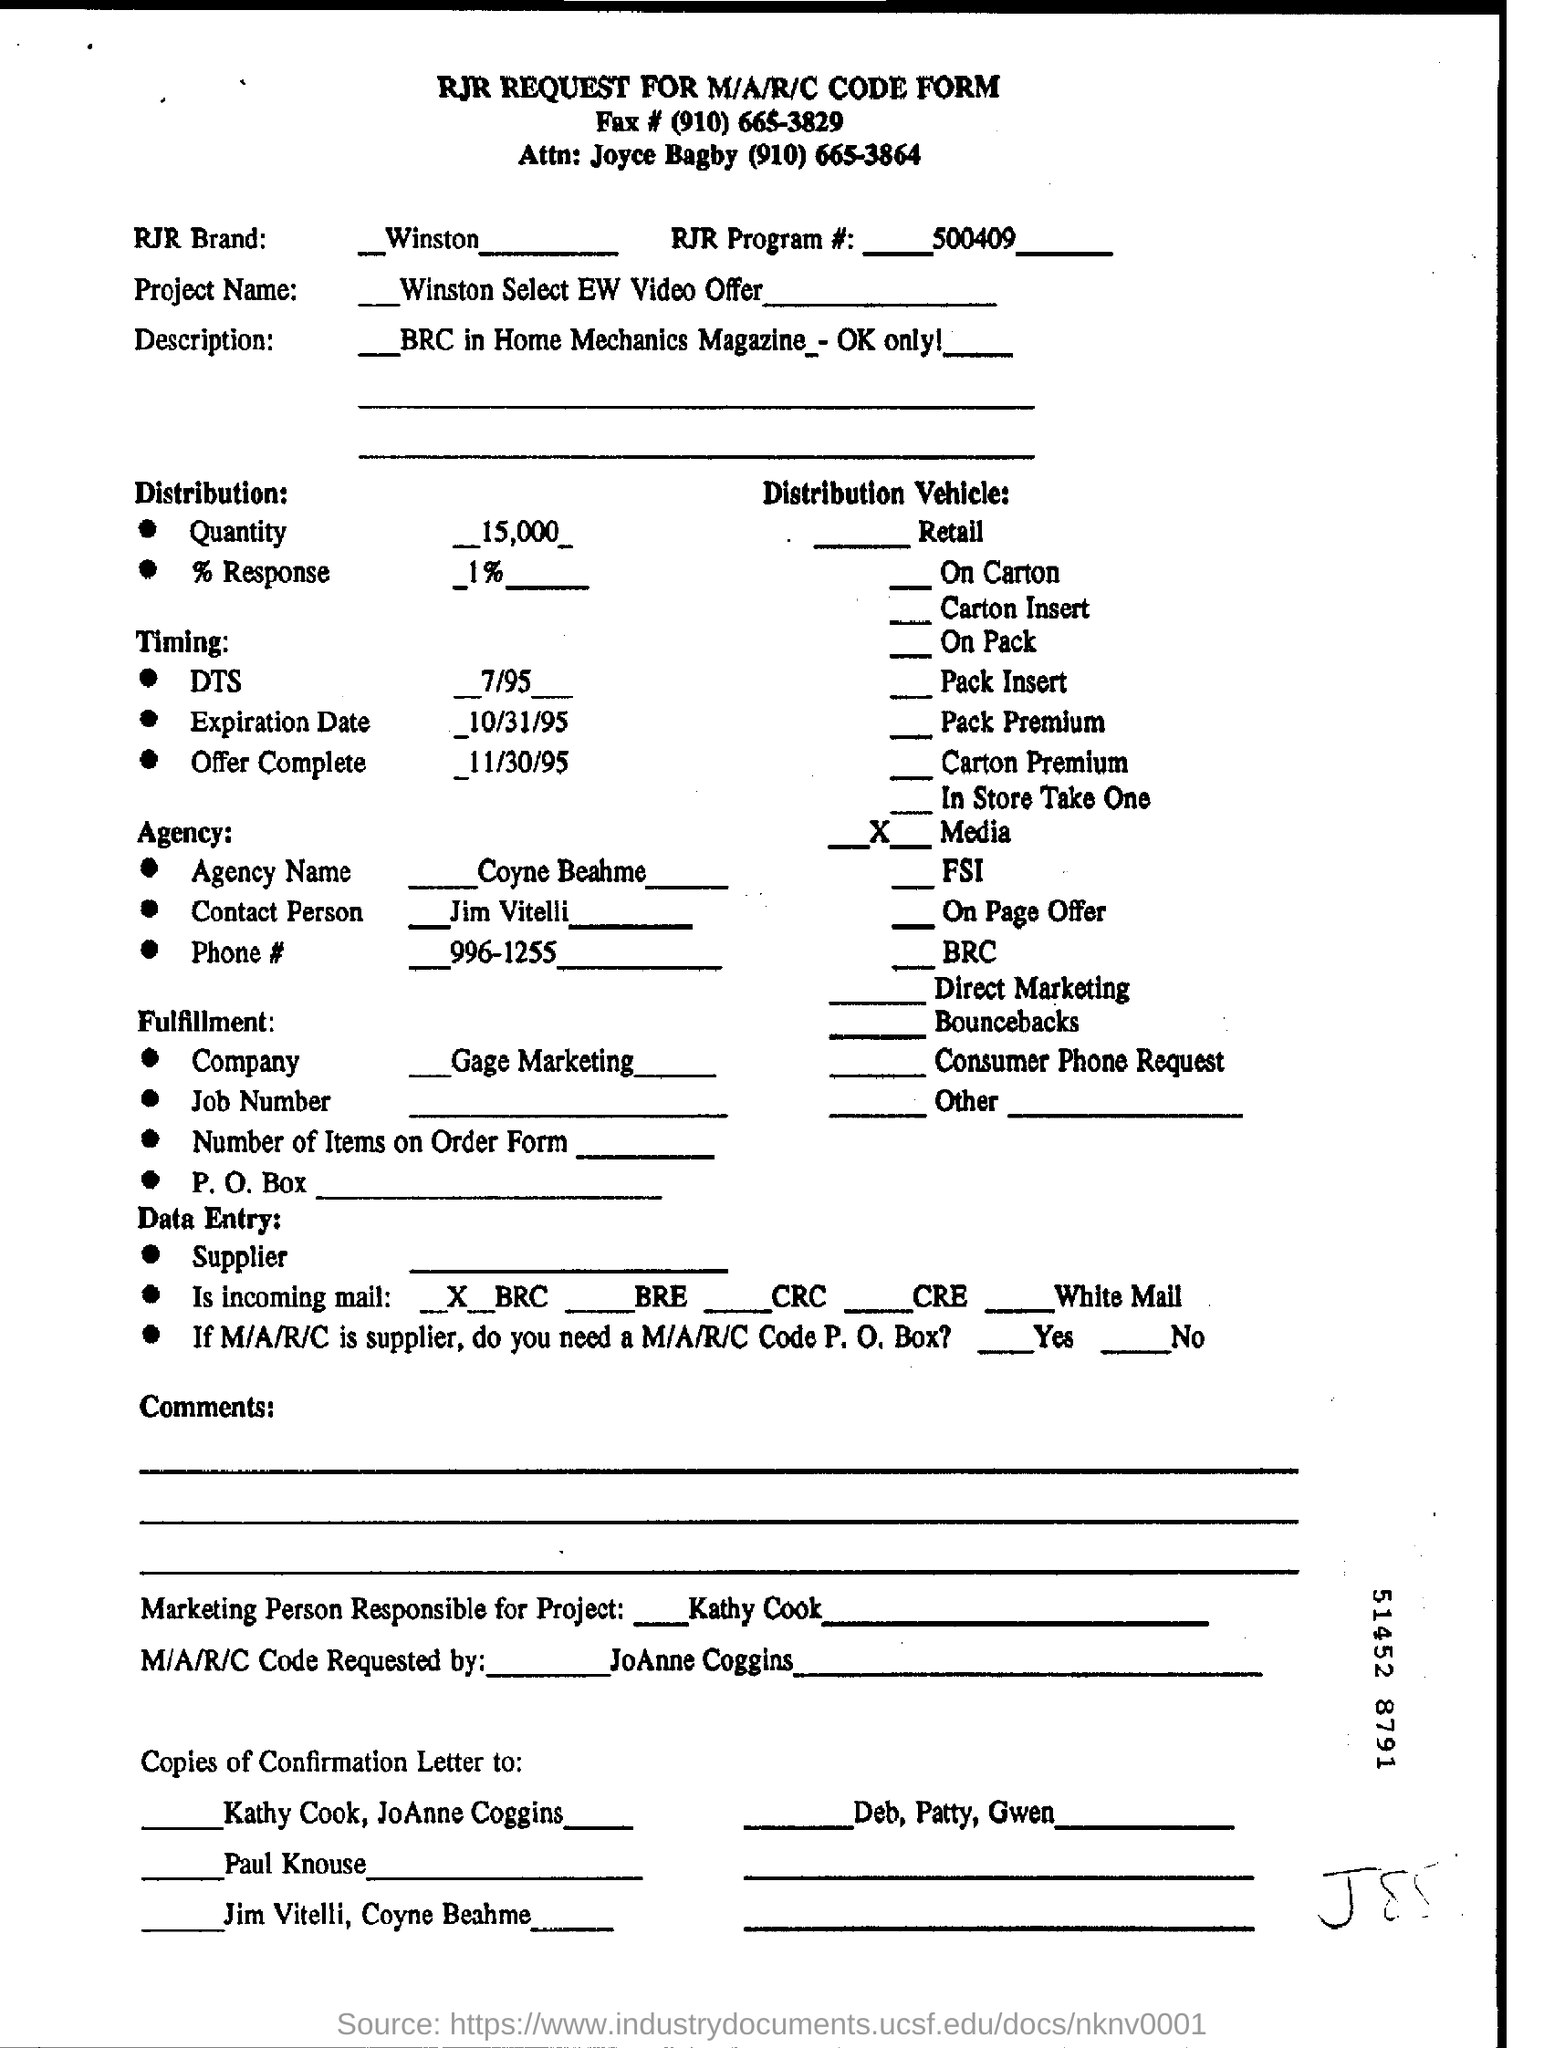What is the RJR Program # ?
Your response must be concise. 500409. What is the Project Name?
Provide a short and direct response. Winston select ew video offer. What is the RJR Brand # ?
Your answer should be compact. Winston. What is the Agency Name?
Provide a succinct answer. Coyne beahme. Which is the Fulfillment Company?
Offer a terse response. Gage Marketing. Who is the Marketing Person Responsible for project?
Your answer should be very brief. ____ kathy cook. Who requested the M/A/R/C Code?
Keep it short and to the point. JoAnne Coggins. 